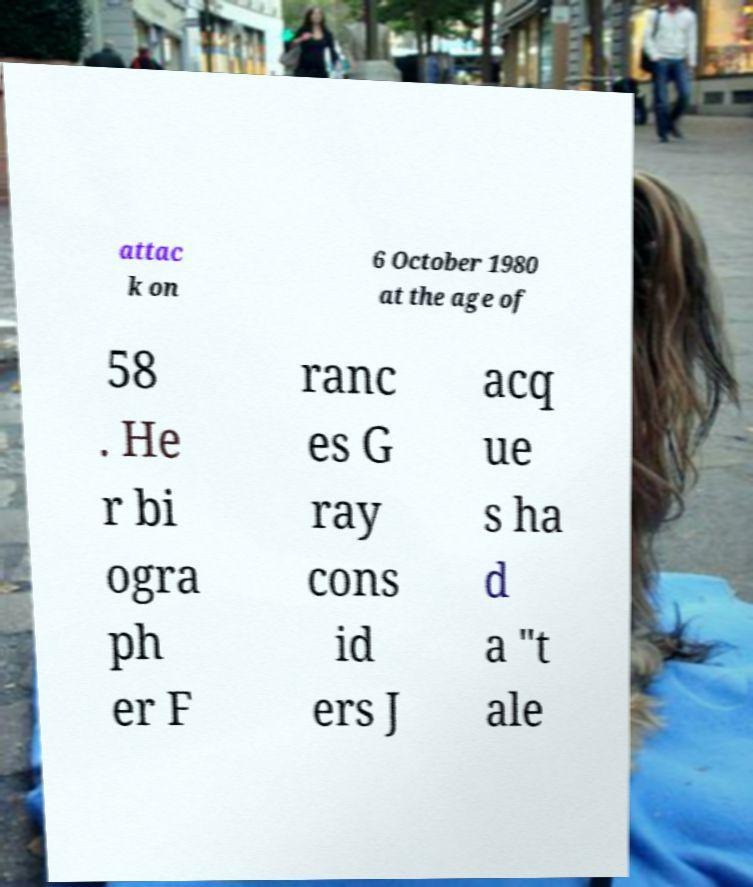Can you accurately transcribe the text from the provided image for me? attac k on 6 October 1980 at the age of 58 . He r bi ogra ph er F ranc es G ray cons id ers J acq ue s ha d a "t ale 